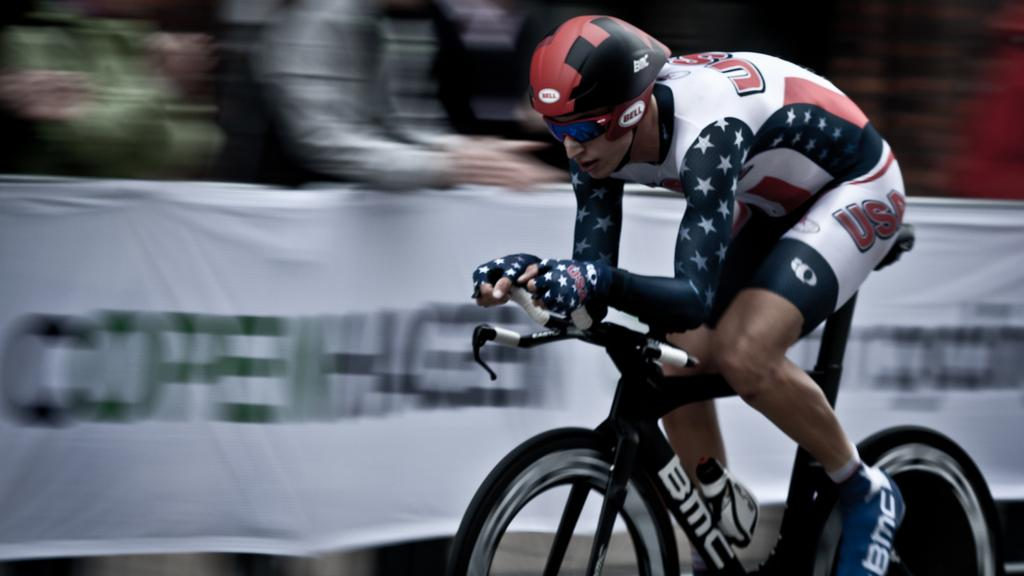What can be observed about the background of the image? The background of the image is blurry. What is present in the image besides the man and the bicycle? There is a banner in the image. What is the man doing in the image? The man is riding the bicycle. What safety equipment is the man wearing while riding the bicycle? The man is wearing a helmet and goggles. What type of structure can be seen in the background of the image? There is no structure visible in the background of the image; it is blurry. What letters are being kicked by the man in the image? The man is not kicking any letters in the image; he is riding a bicycle. 